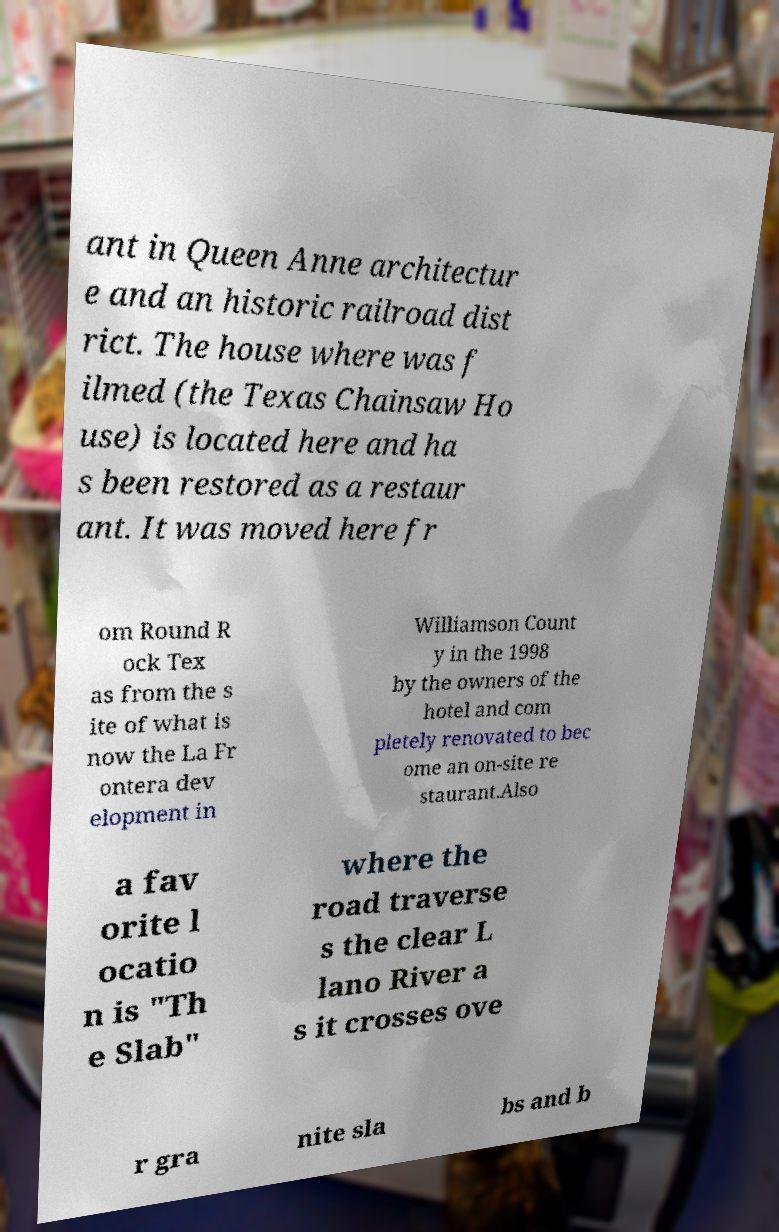Please read and relay the text visible in this image. What does it say? ant in Queen Anne architectur e and an historic railroad dist rict. The house where was f ilmed (the Texas Chainsaw Ho use) is located here and ha s been restored as a restaur ant. It was moved here fr om Round R ock Tex as from the s ite of what is now the La Fr ontera dev elopment in Williamson Count y in the 1998 by the owners of the hotel and com pletely renovated to bec ome an on-site re staurant.Also a fav orite l ocatio n is "Th e Slab" where the road traverse s the clear L lano River a s it crosses ove r gra nite sla bs and b 